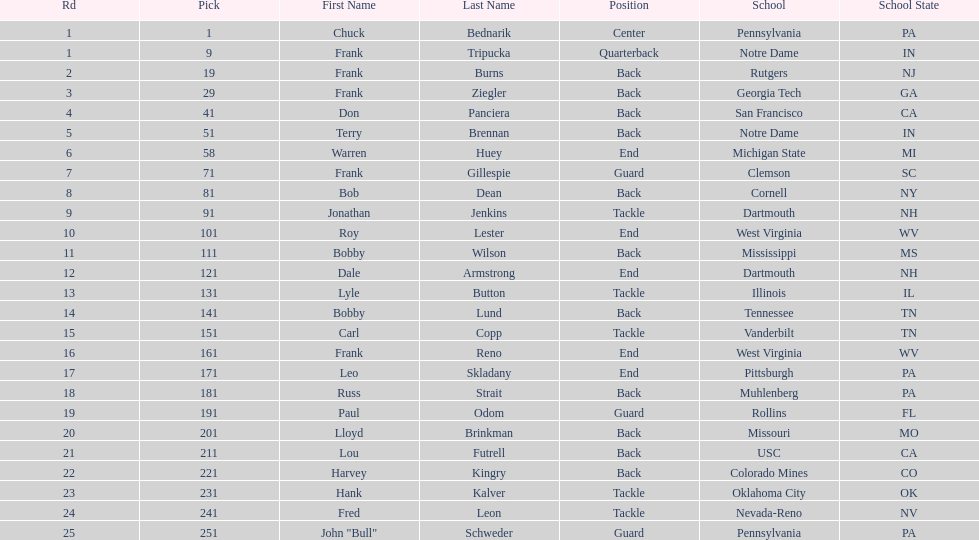Who has same position as frank gillespie? Paul Odom, John "Bull" Schweder. 